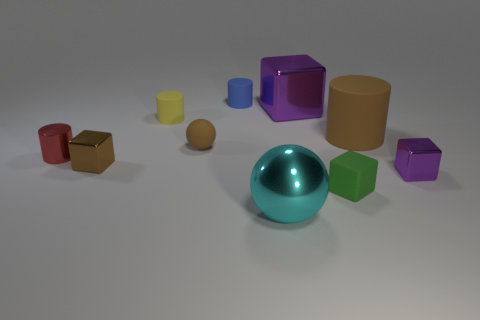Subtract all metallic cubes. How many cubes are left? 1 Subtract all blue cylinders. How many cylinders are left? 3 Subtract all cylinders. How many objects are left? 6 Subtract 2 spheres. How many spheres are left? 0 Subtract all yellow spheres. Subtract all purple cubes. How many spheres are left? 2 Subtract all gray cylinders. How many red cubes are left? 0 Subtract all brown matte things. Subtract all brown balls. How many objects are left? 7 Add 1 small red metal things. How many small red metal things are left? 2 Add 1 purple objects. How many purple objects exist? 3 Subtract 1 brown spheres. How many objects are left? 9 